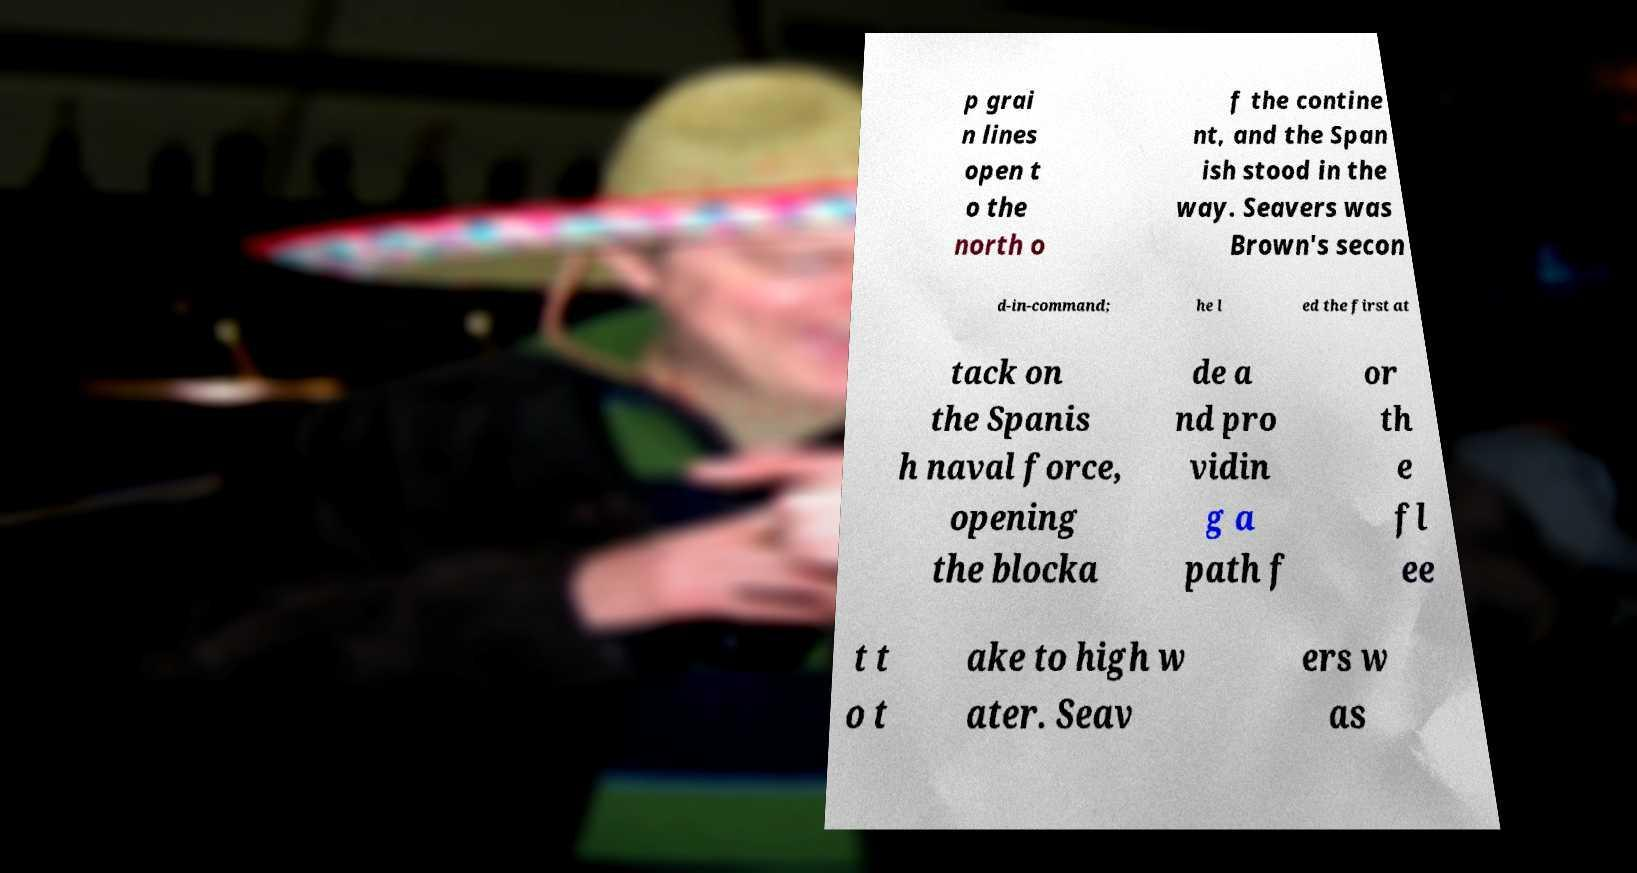Please identify and transcribe the text found in this image. p grai n lines open t o the north o f the contine nt, and the Span ish stood in the way. Seavers was Brown's secon d-in-command; he l ed the first at tack on the Spanis h naval force, opening the blocka de a nd pro vidin g a path f or th e fl ee t t o t ake to high w ater. Seav ers w as 